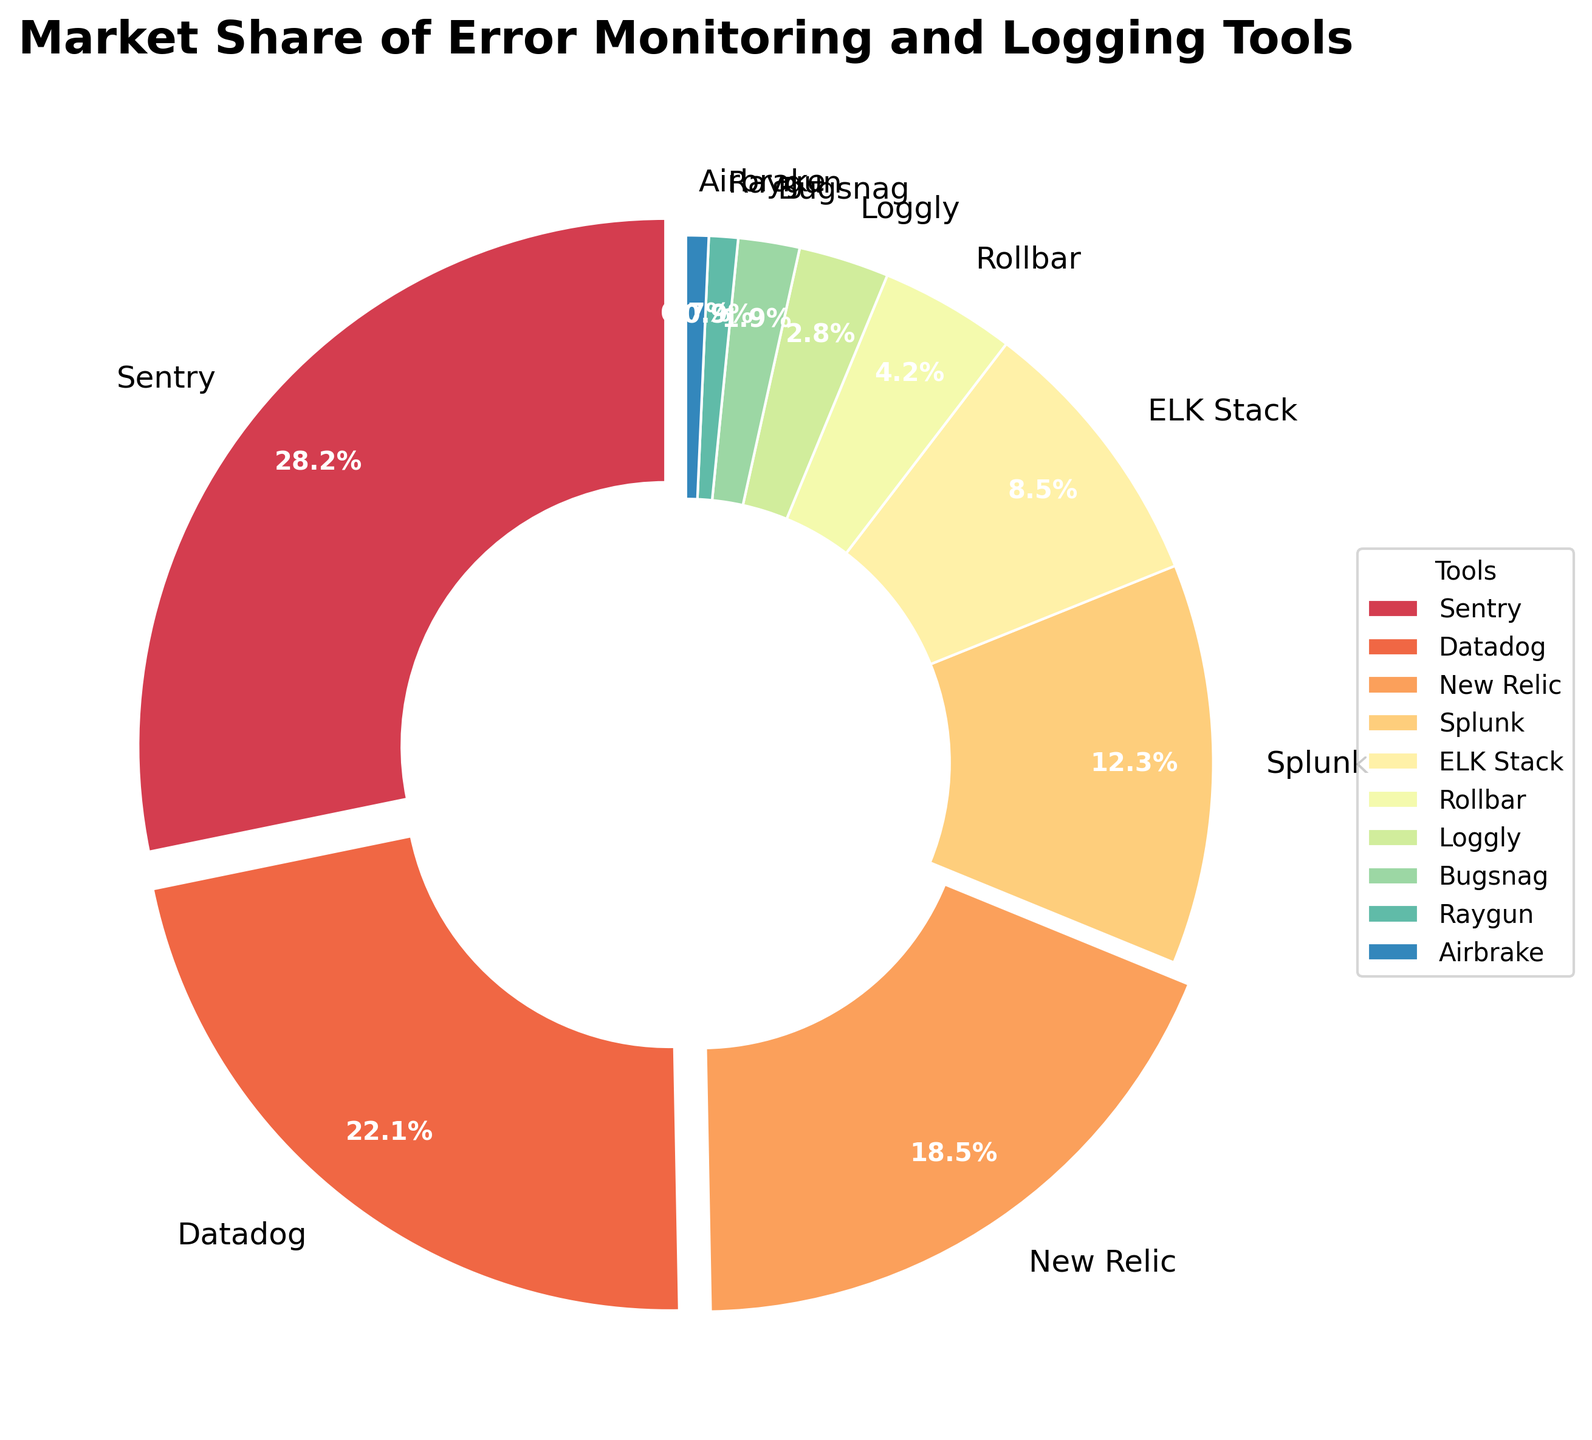What is the market share of the tool with the highest share? The tool with the highest market share is Sentry, which has a share of 28.5%. This can be directly read from the pie chart's labels.
Answer: 28.5% Which tool has a higher market share, Datadog or New Relic? By comparing the market shares shown in the pie chart, Datadog has a market share of 22.3% while New Relic has a market share of 18.7%.
Answer: Datadog What is the total market share for tools with a market share below 5%? To find the total market share for tools with a market share below 5%, add the shares of Rollbar (4.2%), Loggly (2.8%), Bugsnag (1.9%), Raygun (0.9%), and Airbrake (0.7%). So, 4.2 + 2.8 + 1.9 + 0.9 + 0.7 = 10.5%.
Answer: 10.5% How does the market share of Sentry compare to ELK Stack? Sentry has a market share of 28.5% while ELK Stack has a market share of 8.6%. Sentry's market share is higher.
Answer: Sentry What is the combined market share of Splunk and ELK Stack? The market share for Splunk is 12.4% and for ELK Stack is 8.6%. Adding these together gives 12.4 + 8.6 = 21.0%.
Answer: 21.0% Which tools have their wedges exploded in the pie chart? Wedges are exploded if their market share is greater than 15%. The tools that meet this criterion are Sentry, Datadog, and New Relic.
Answer: Sentry, Datadog, New Relic What is the average market share of the tools presented? To find the average market share, sum all the market shares and then divide by the number of tools. The total is 100%, and there are 10 tools. The average is 100/10 = 10.0%.
Answer: 10.0% Which tool has a lower market share, Bugsnag or Raygun? By comparing the market shares, Bugsnag has 1.9% and Raygun has 0.9%. Raygun has the lower market share.
Answer: Raygun 